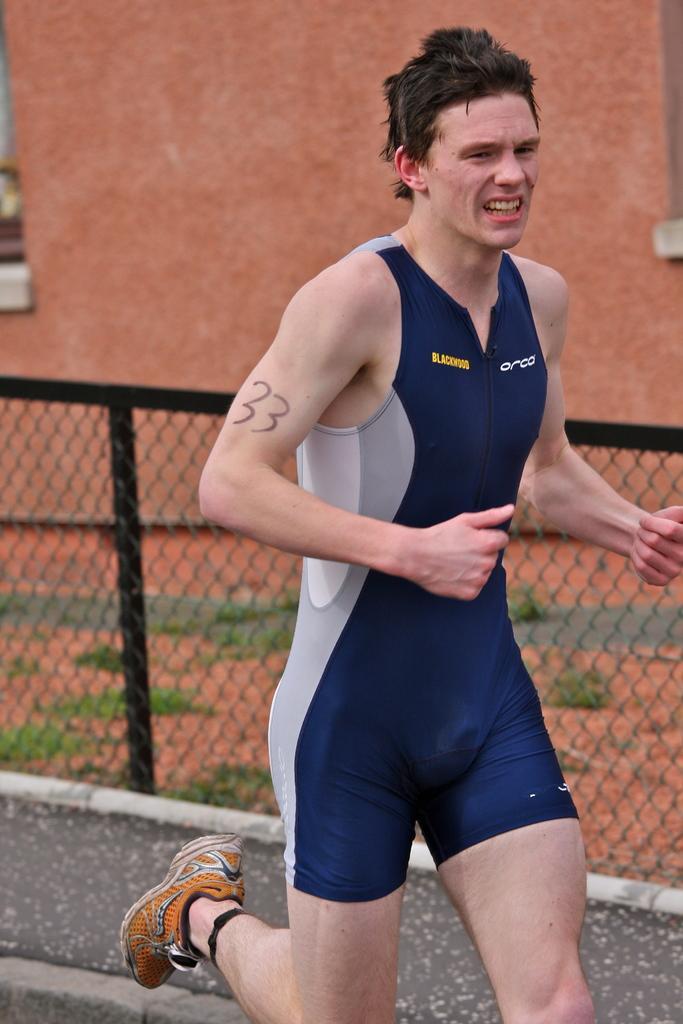How would you summarize this image in a sentence or two? In the image we can see there is a person standing on the road. Behind there is a building. 